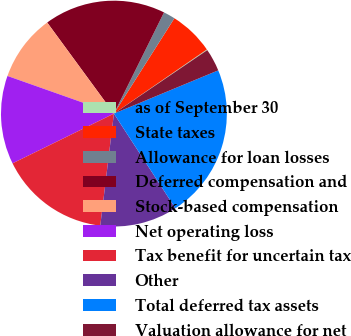<chart> <loc_0><loc_0><loc_500><loc_500><pie_chart><fcel>as of September 30<fcel>State taxes<fcel>Allowance for loan losses<fcel>Deferred compensation and<fcel>Stock-based compensation<fcel>Net operating loss<fcel>Tax benefit for uncertain tax<fcel>Other<fcel>Total deferred tax assets<fcel>Valuation allowance for net<nl><fcel>0.11%<fcel>6.39%<fcel>1.68%<fcel>17.38%<fcel>9.53%<fcel>12.67%<fcel>15.81%<fcel>11.1%<fcel>22.09%<fcel>3.25%<nl></chart> 